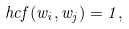<formula> <loc_0><loc_0><loc_500><loc_500>\ h c f ( w _ { i } , w _ { j } ) = 1 ,</formula> 